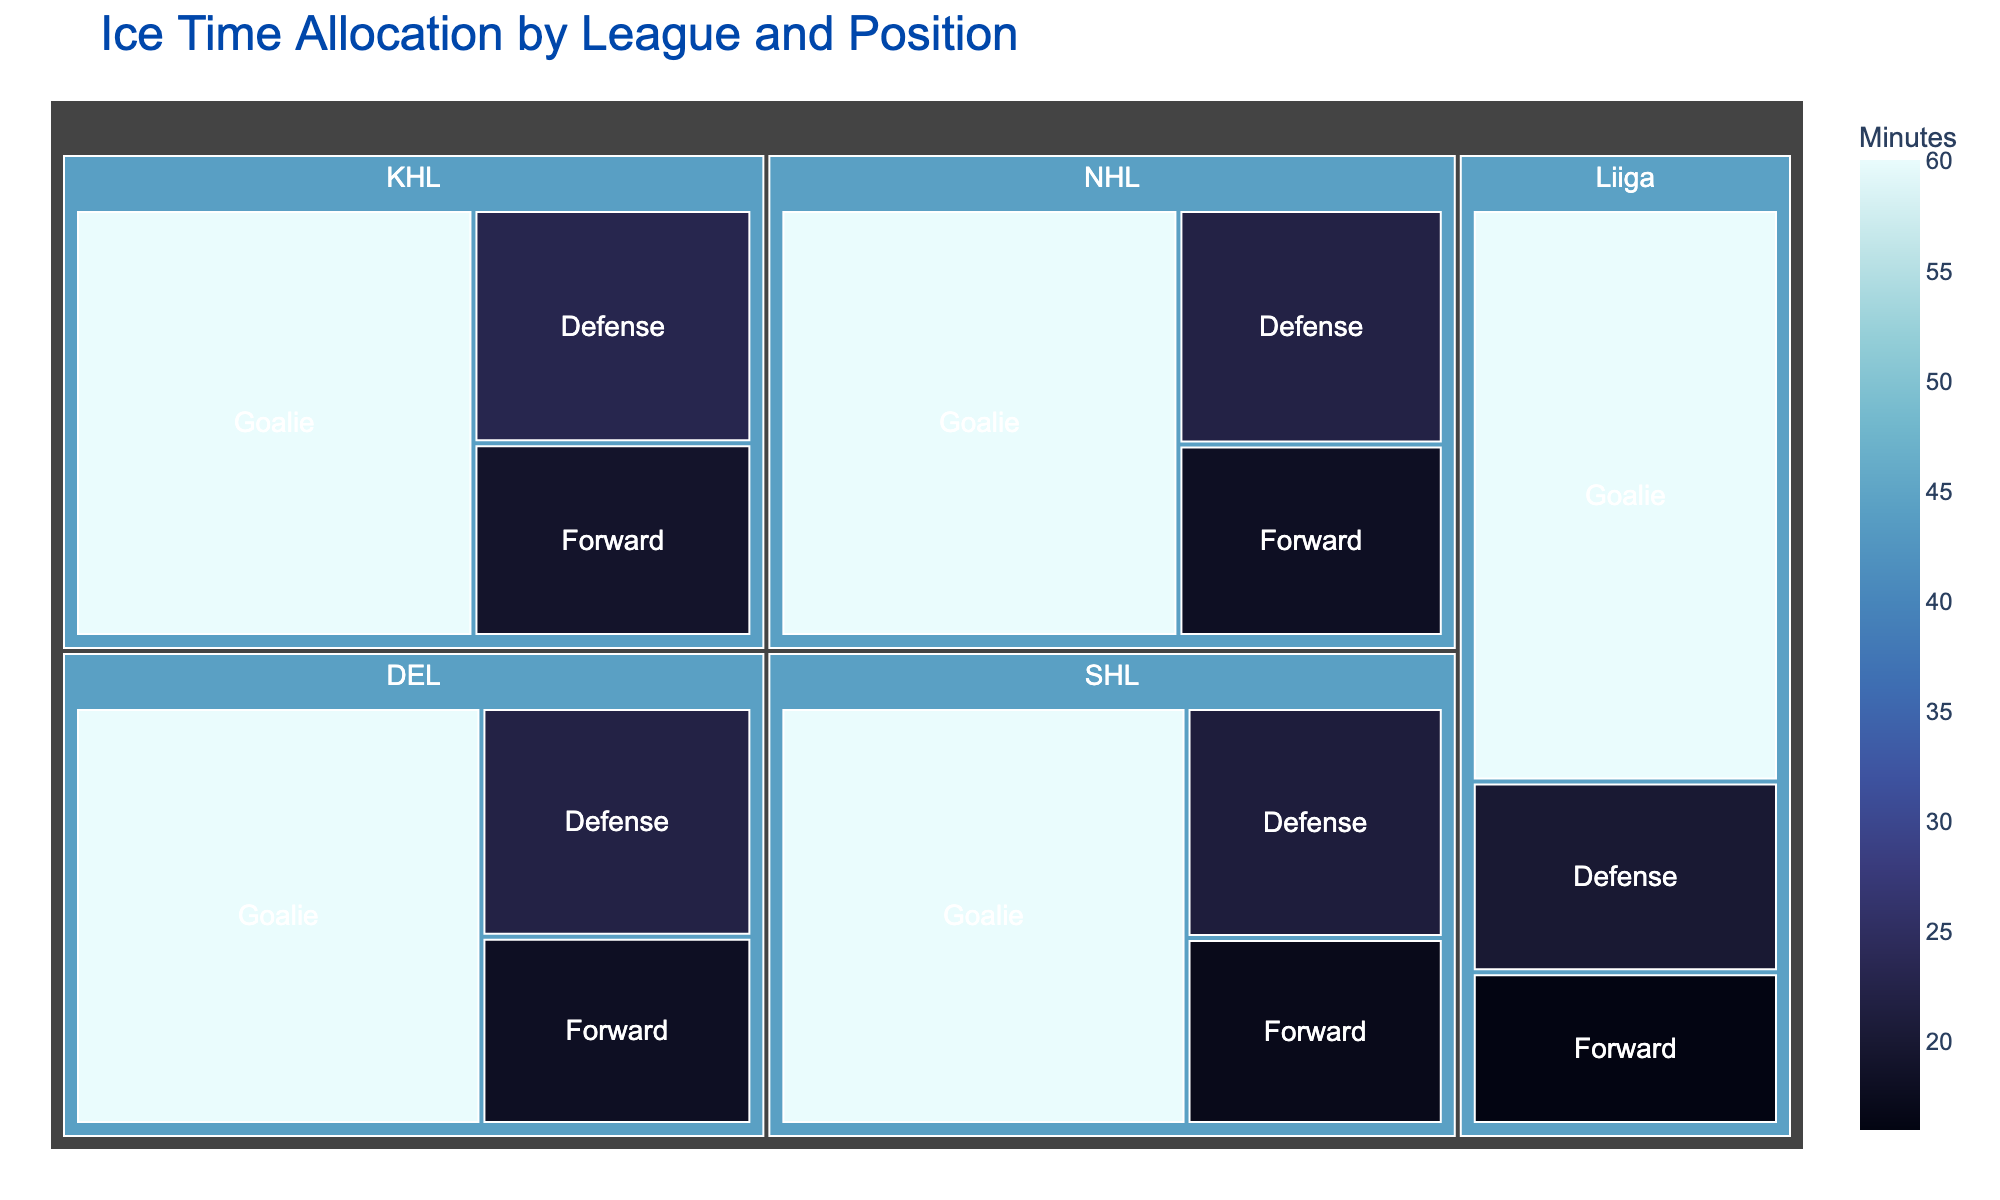What is the total ice time allocated to the Goalie position in all leagues? You need to sum the minutes for Goalies across all leagues, which are all 60 minutes: (NHL: 60 + KHL: 60 + SHL: 60 + Liiga: 60 + DEL: 60 = 300)
Answer: 300 minutes Which position has the highest allocation of ice time in the SHL? The treemap shows that in the SHL, the Goalie position has the highest allocation with 60 minutes.
Answer: Goalie How does the ice time for Forwards in the NHL compare to Forwards in the Liiga? The ice time for Forwards in the NHL is 18 minutes, while in the Liiga it is 16 minutes, so NHL Forwards have 2 more minutes.
Answer: NHL Forwards have 2 more minutes Which league allocates the least ice time to Defense positions? Compare the Defense ice times across leagues: NHL (22), KHL (23), SHL (21), Liiga (20), DEL (22). The league with the lowest allocation is Liiga with 20 minutes.
Answer: Liiga What is the average ice time for Defense players across all leagues? Sum the minutes for Defense across all leagues (NHL: 22 + KHL: 23 + SHL: 21 + Liiga: 20 + DEL: 22 = 108) and divide by 5 leagues: 108 / 5 = 21.6 minutes
Answer: 21.6 minutes Which league has the highest total ice time allocation when all positions are combined? Calculate the total per league: NHL (18+22+60=100), KHL (19+23+60=102), SHL (17+21+60=98), Liiga (16+20+60=96), DEL (18+22+60=100). The KHL has the highest allocation with 102 minutes.
Answer: KHL What is the difference in ice time allocation between the Goalie and Forward positions in the DEL? Subtract the Forward ice time (18) from the Goalie ice time (60) in the DEL: 60 - 18 = 42 minutes.
Answer: 42 minutes Which position consistently has the most ice time across all leagues? By examining the treemap, it's clear that the Goalie position consistently has the most ice time in every league (60 minutes).
Answer: Goalie 